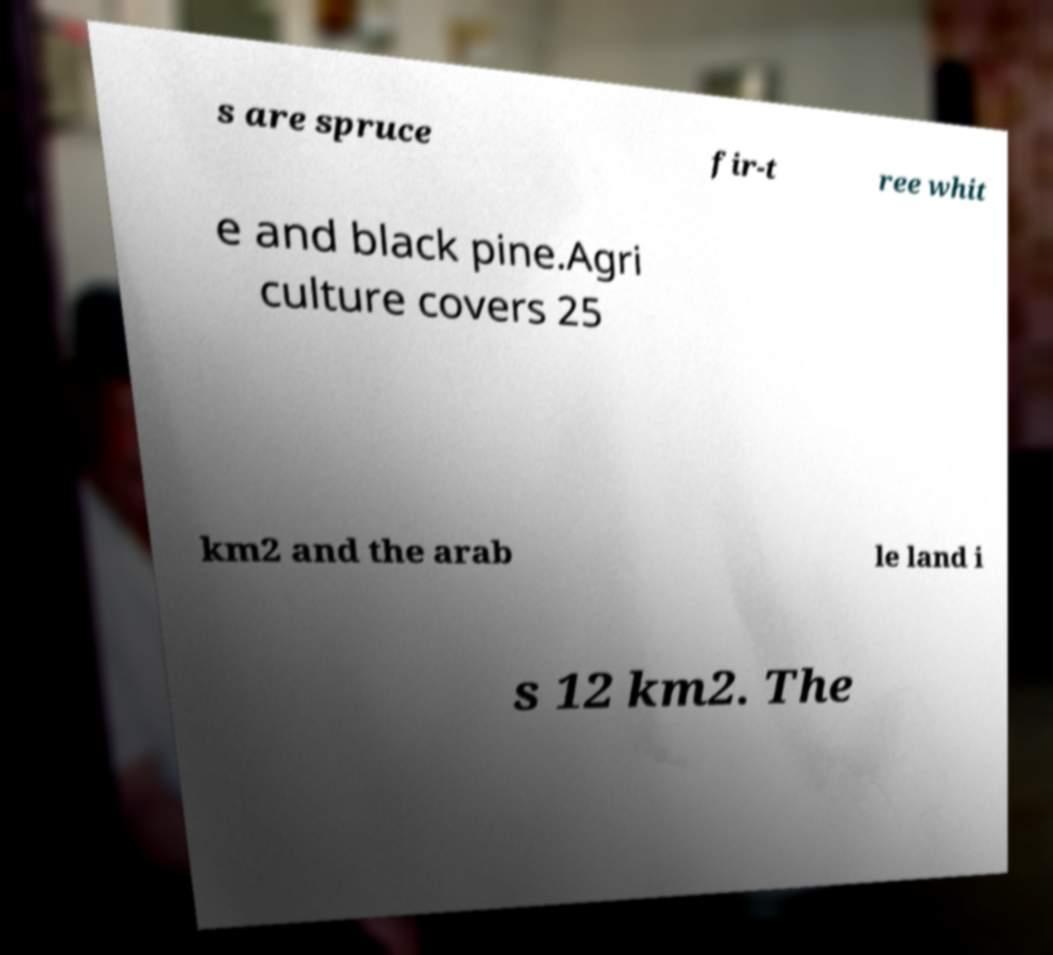Could you extract and type out the text from this image? s are spruce fir-t ree whit e and black pine.Agri culture covers 25 km2 and the arab le land i s 12 km2. The 